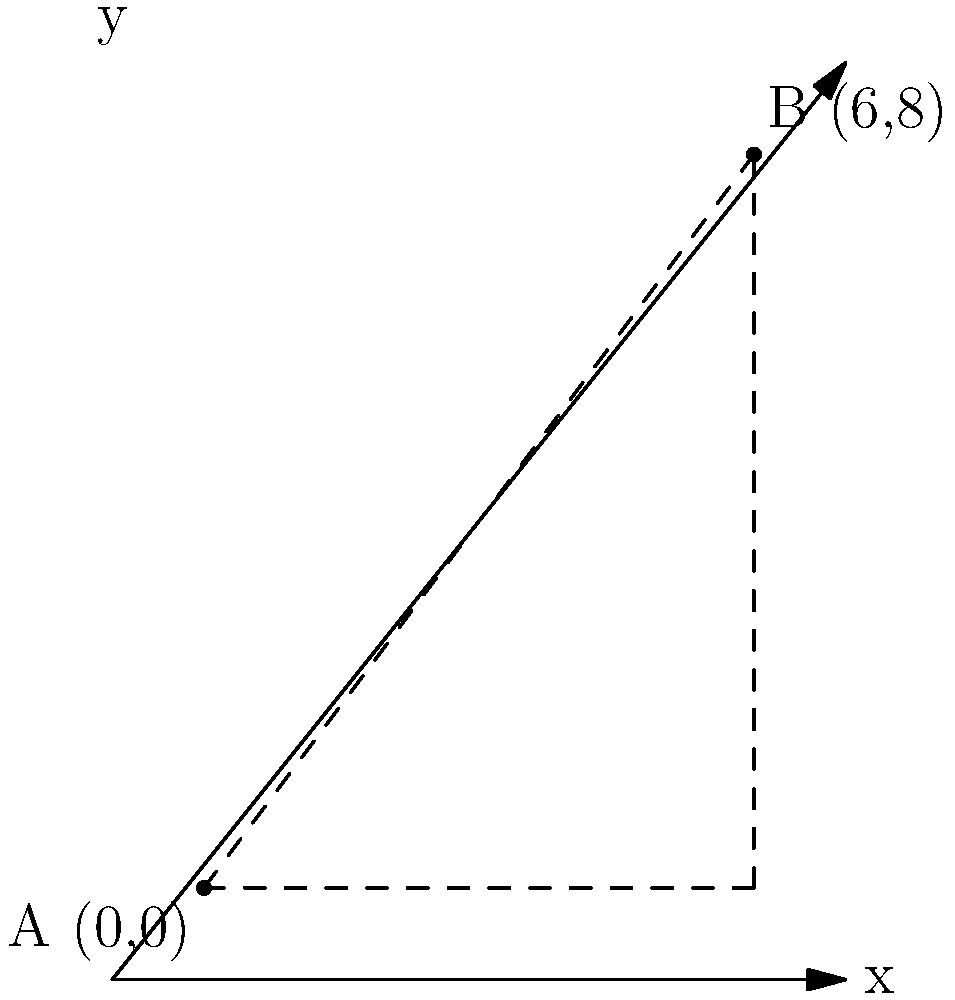As a history book writer studying political shifts, you're analyzing the geographical distance between two significant locations during a government transition. Location A, representing the old capital, is at coordinates (0,0), while Location B, the new seat of power, is at coordinates (6,8) on a map where each unit represents 100 kilometers. Using the distance formula, calculate the direct distance between these two historically important locations. To solve this problem, we'll use the distance formula derived from the Pythagorean theorem:

$$d = \sqrt{(x_2 - x_1)^2 + (y_2 - y_1)^2}$$

Where $(x_1, y_1)$ represents the coordinates of point A, and $(x_2, y_2)$ represents the coordinates of point B.

Step 1: Identify the coordinates
A (0,0): $x_1 = 0, y_1 = 0$
B (6,8): $x_2 = 6, y_2 = 8$

Step 2: Plug the coordinates into the distance formula
$$d = \sqrt{(6 - 0)^2 + (8 - 0)^2}$$

Step 3: Simplify the expressions inside the parentheses
$$d = \sqrt{6^2 + 8^2}$$

Step 4: Calculate the squares
$$d = \sqrt{36 + 64}$$

Step 5: Add the values under the square root
$$d = \sqrt{100}$$

Step 6: Simplify the square root
$$d = 10$$

Step 7: Interpret the result
Since each unit represents 100 kilometers, we multiply our result by 100:
$$10 \times 100 = 1000 \text{ kilometers}$$

Therefore, the direct distance between the old capital (Location A) and the new seat of power (Location B) is 1000 kilometers.
Answer: 1000 kilometers 